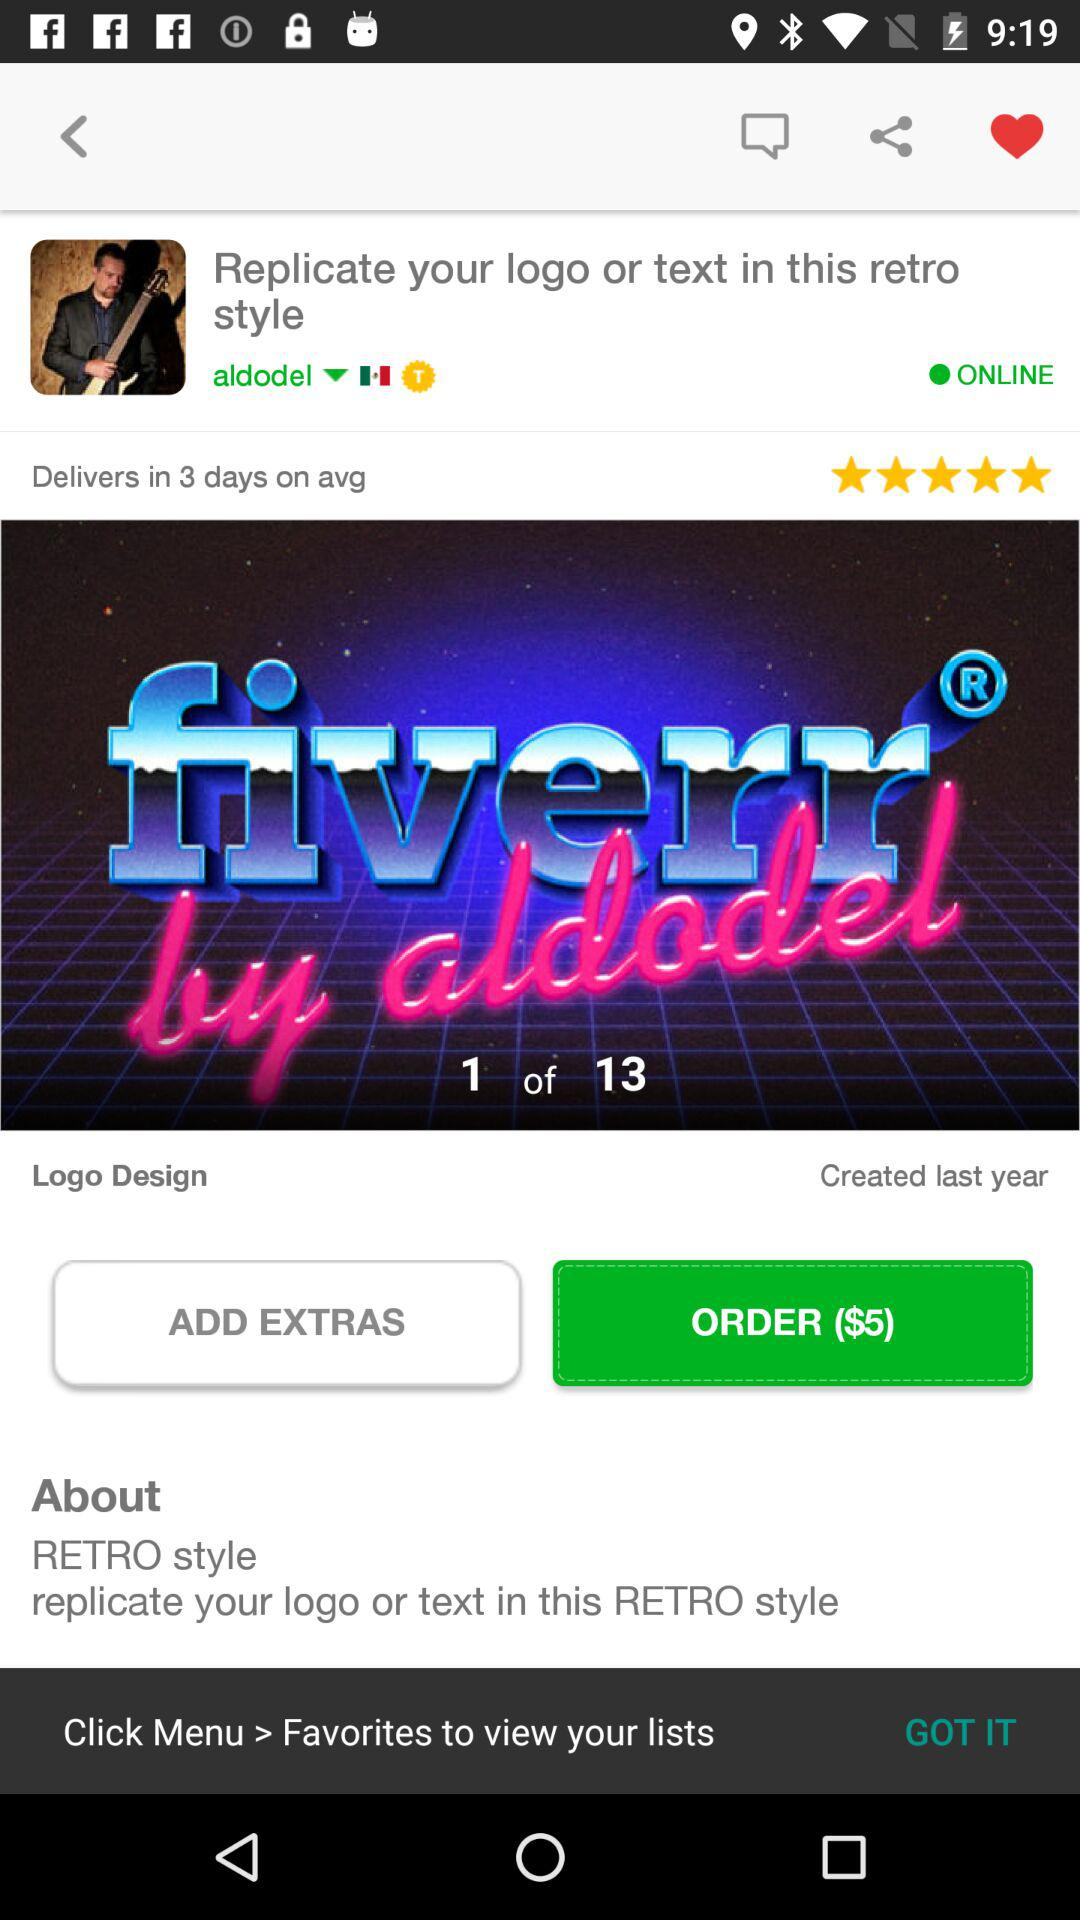How many slides in total are there for "Logo Design"? There are 13 slides for "Logo Design". 